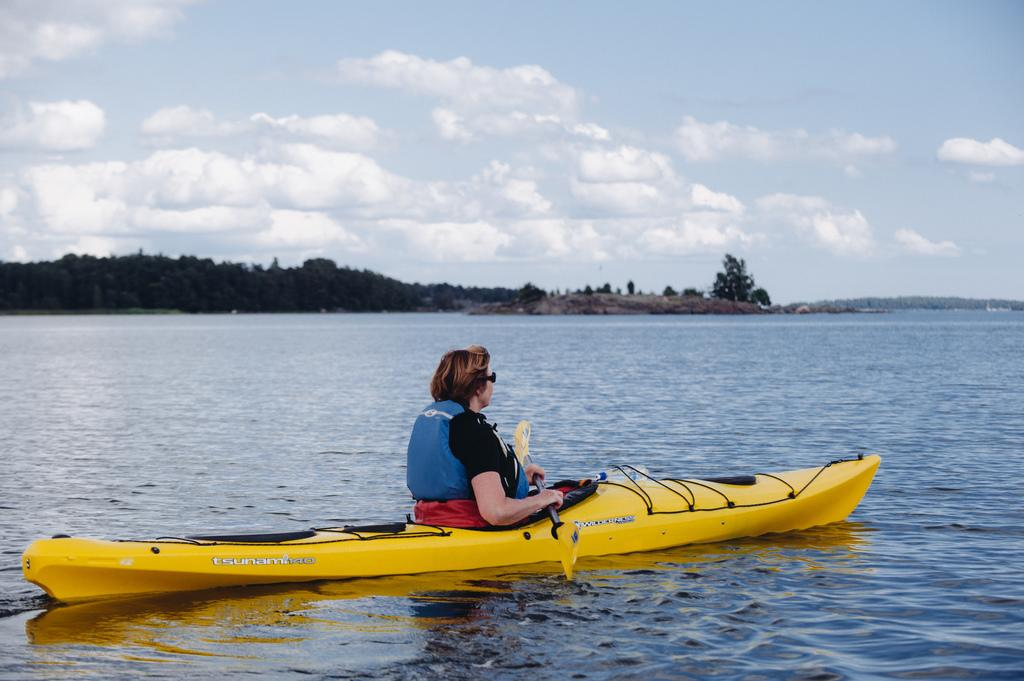Who is present in the image? There is a woman in the image. What is the woman holding in the image? The woman is holding a paddle. Where is the woman sitting in the image? The woman is sitting on a boat. What is the boat's location in the image? The boat is on the water. What can be seen in the background of the image? There are trees and the sky visible in the background of the image. What type of anger is the woman expressing in the image? There is no indication of anger in the image; the woman appears to be engaged in a recreational activity (paddling a boat). What does the woman's mom think about her being on the boat? The image does not provide any information about the woman's mom or her opinion on the woman being on the boat. 